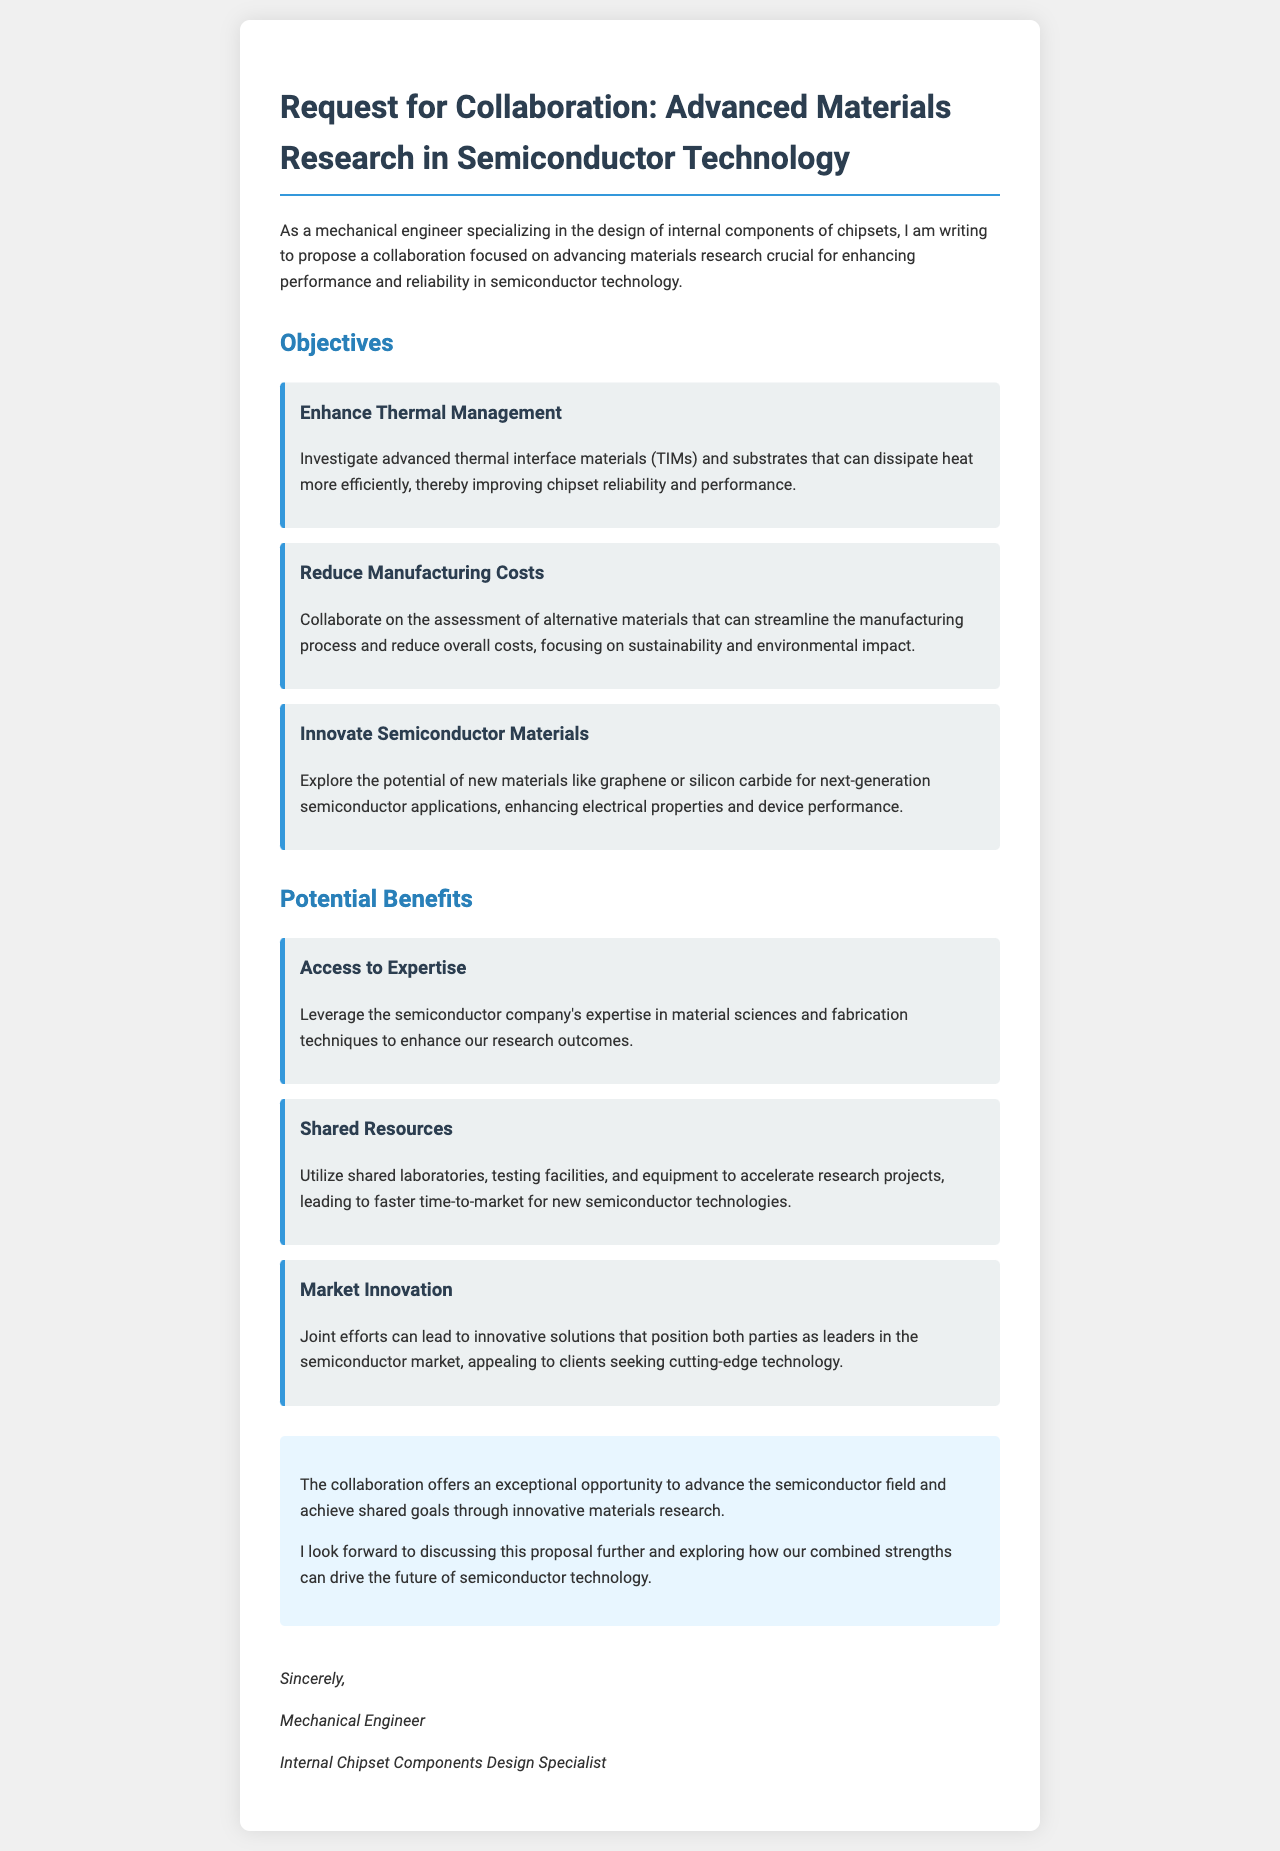What is the main focus of the collaboration proposal? The main focus of the collaboration proposal is on advancing materials research crucial for enhancing performance and reliability in semiconductor technology.
Answer: semiconductor technology Who is the letter addressed to? The letter is written to a semiconductor company, but the specific name is not mentioned in the document.
Answer: semiconductor company What material is mentioned for enhancing electrical properties? The document mentions exploring new materials like graphene or silicon carbide for next-generation semiconductor applications.
Answer: graphene or silicon carbide Which objective aims to streamline the manufacturing process? The objective that aims to streamline the manufacturing process is to assess alternative materials that focus on sustainability and environmental impact.
Answer: Reduce Manufacturing Costs What potential benefit involves utilizing shared testing facilities? The potential benefit involving shared testing facilities is to accelerate research projects, leading to faster time-to-market for new semiconductor technologies.
Answer: Shared Resources What does the conclusion highlight about the collaboration? The conclusion highlights that the collaboration offers an exceptional opportunity to advance the semiconductor field and achieve shared goals through innovative materials research.
Answer: exceptional opportunity How many areas of objectives are listed in the document? There are three areas of objectives listed in the document.
Answer: three What is the title of the letter? The title of the letter is "Request for Collaboration: Advanced Materials Research in Semiconductor Technology."
Answer: Request for Collaboration: Advanced Materials Research in Semiconductor Technology What is the profession of the letter's author? The profession of the letter's author is a mechanical engineer.
Answer: mechanical engineer 